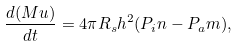Convert formula to latex. <formula><loc_0><loc_0><loc_500><loc_500>\frac { d ( M u ) } { d t } = 4 \pi R _ { s } h ^ { 2 } ( P _ { i } n - P _ { a } m ) ,</formula> 